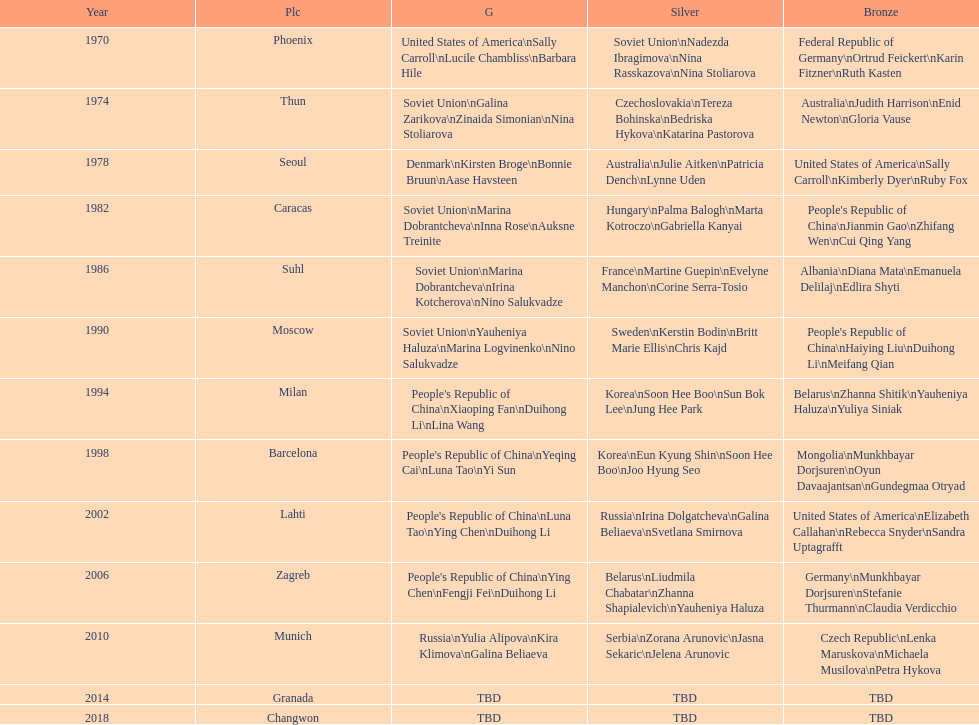What is the number of total bronze medals that germany has won? 1. 